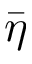<formula> <loc_0><loc_0><loc_500><loc_500>\bar { \eta }</formula> 